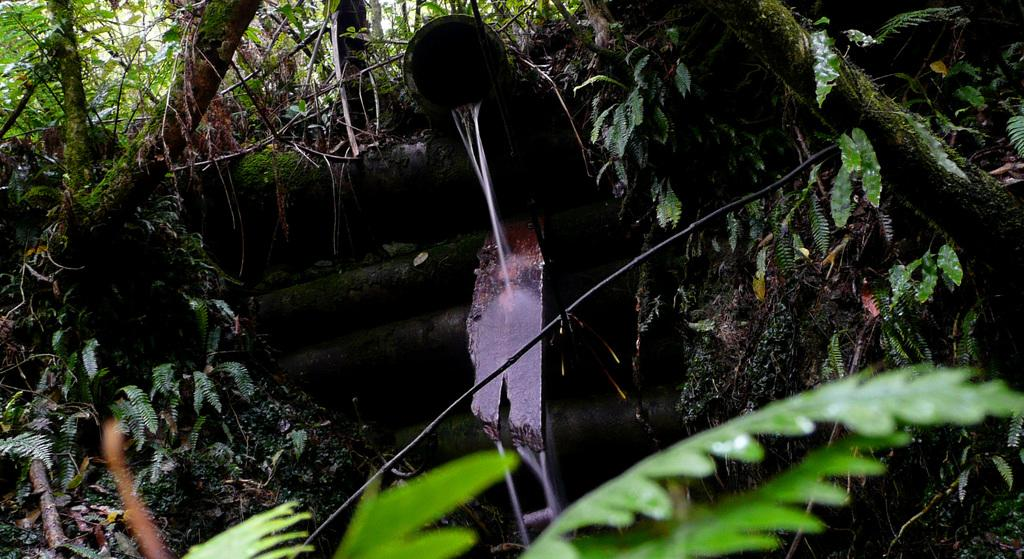What type of vegetation can be seen in the image? There are trees in the image. What natural element is visible in the image besides the trees? There is water visible in the image. Where is the knife located in the image? There is no knife present in the image. What type of park can be seen in the image? There is no park present in the image; it only features trees and water. 